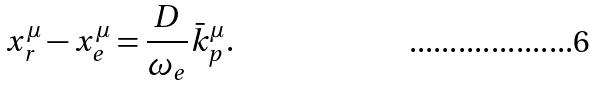Convert formula to latex. <formula><loc_0><loc_0><loc_500><loc_500>x ^ { \mu } _ { r } - x ^ { \mu } _ { e } = \frac { D } { \omega _ { e } } \bar { k } _ { p } ^ { \mu } .</formula> 